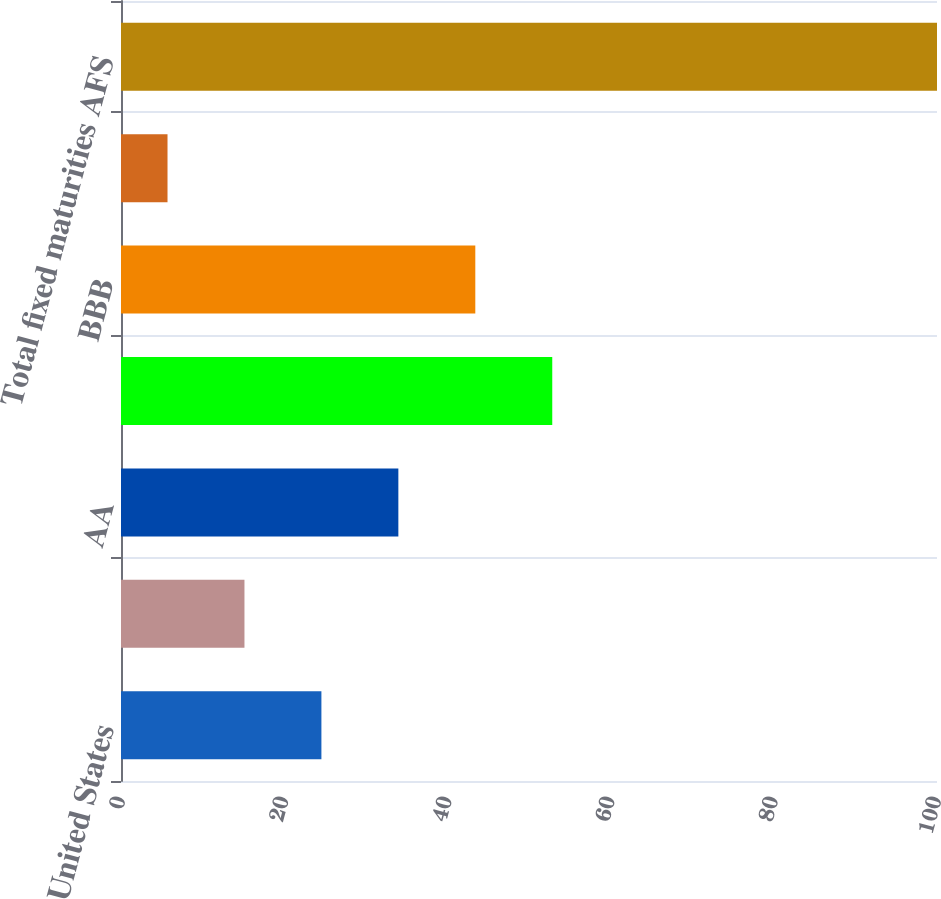Convert chart. <chart><loc_0><loc_0><loc_500><loc_500><bar_chart><fcel>United States<fcel>AAA<fcel>AA<fcel>A<fcel>BBB<fcel>BB & below<fcel>Total fixed maturities AFS<nl><fcel>24.56<fcel>15.13<fcel>33.99<fcel>52.85<fcel>43.42<fcel>5.7<fcel>100<nl></chart> 